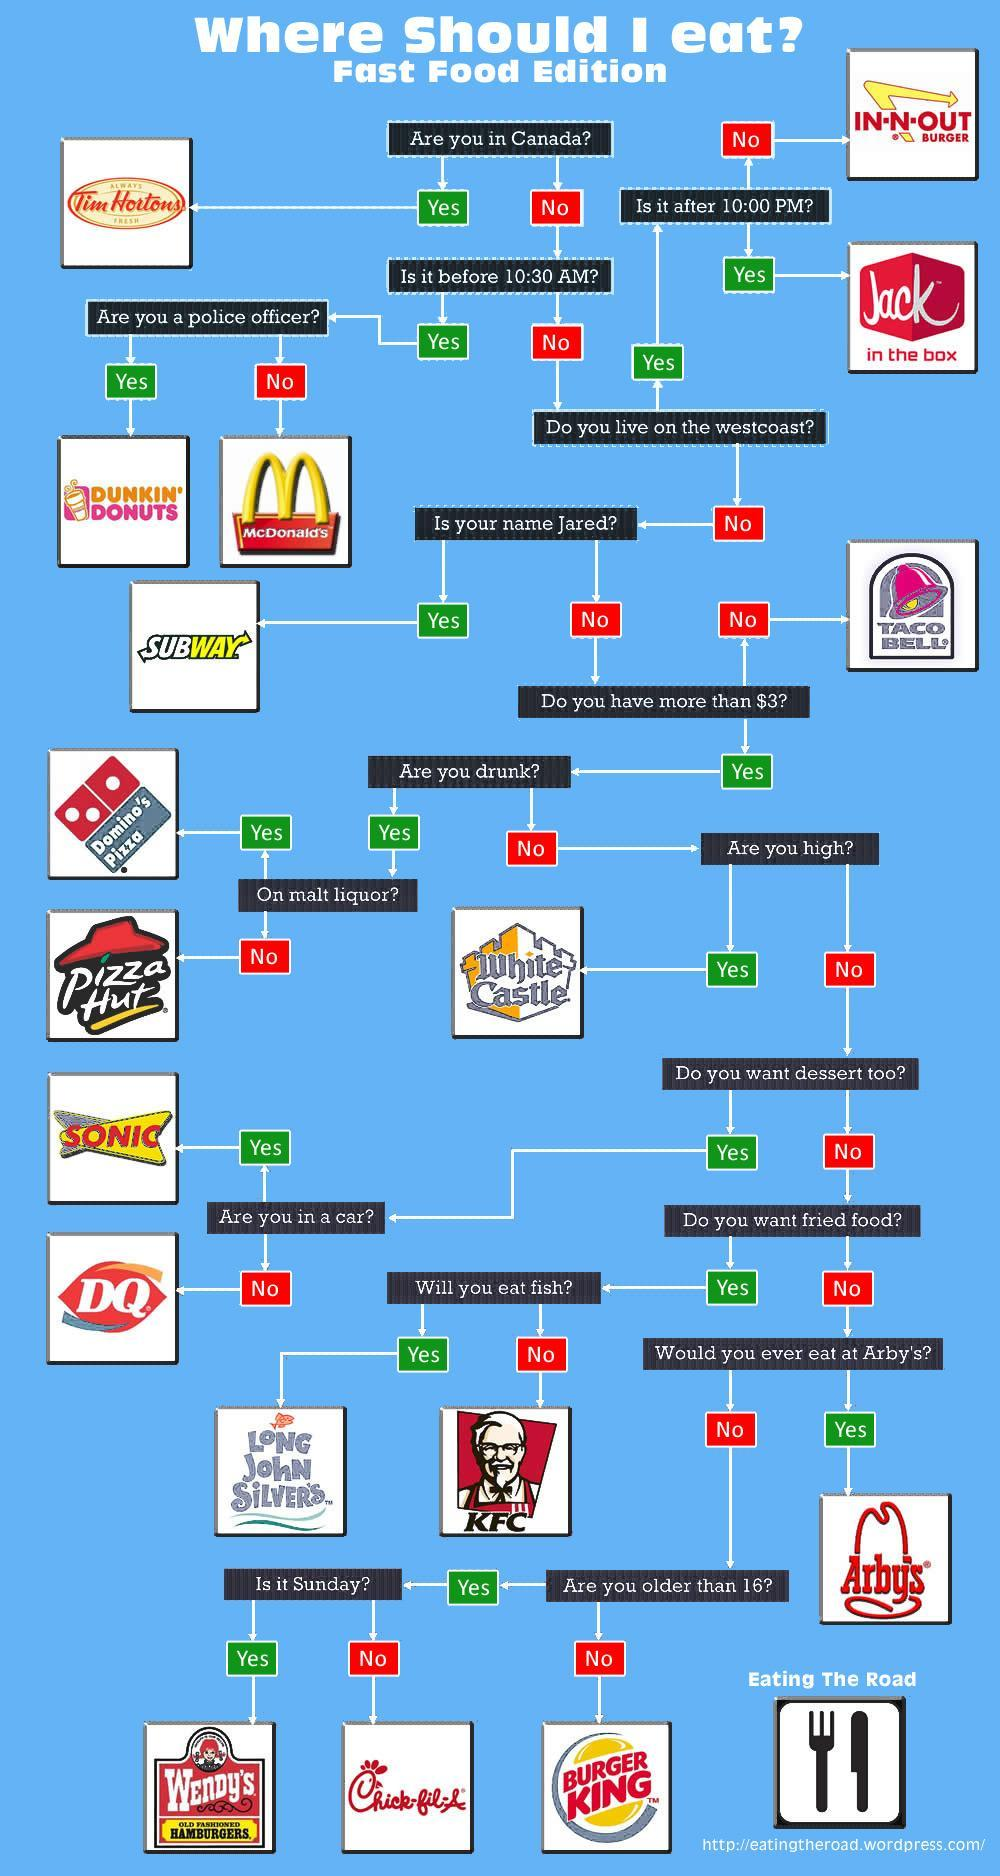where should I eat if I am in Canada
Answer the question with a short phrase. Tim Hortons where should I eat if I am not older than 16? Burger King where should I eat if I dont eat fish KFC How many eating joints have been mentioned here? 18 where should I eat if I dont have more than $3 taco bell Where should I eat if I live in westcoast and it is before 10:00PM IN-N-OUT Burger Where can I go if I am in a car SONIC where should I eat if it is before 10:30 AM and I am not a police officer? McDonalds 